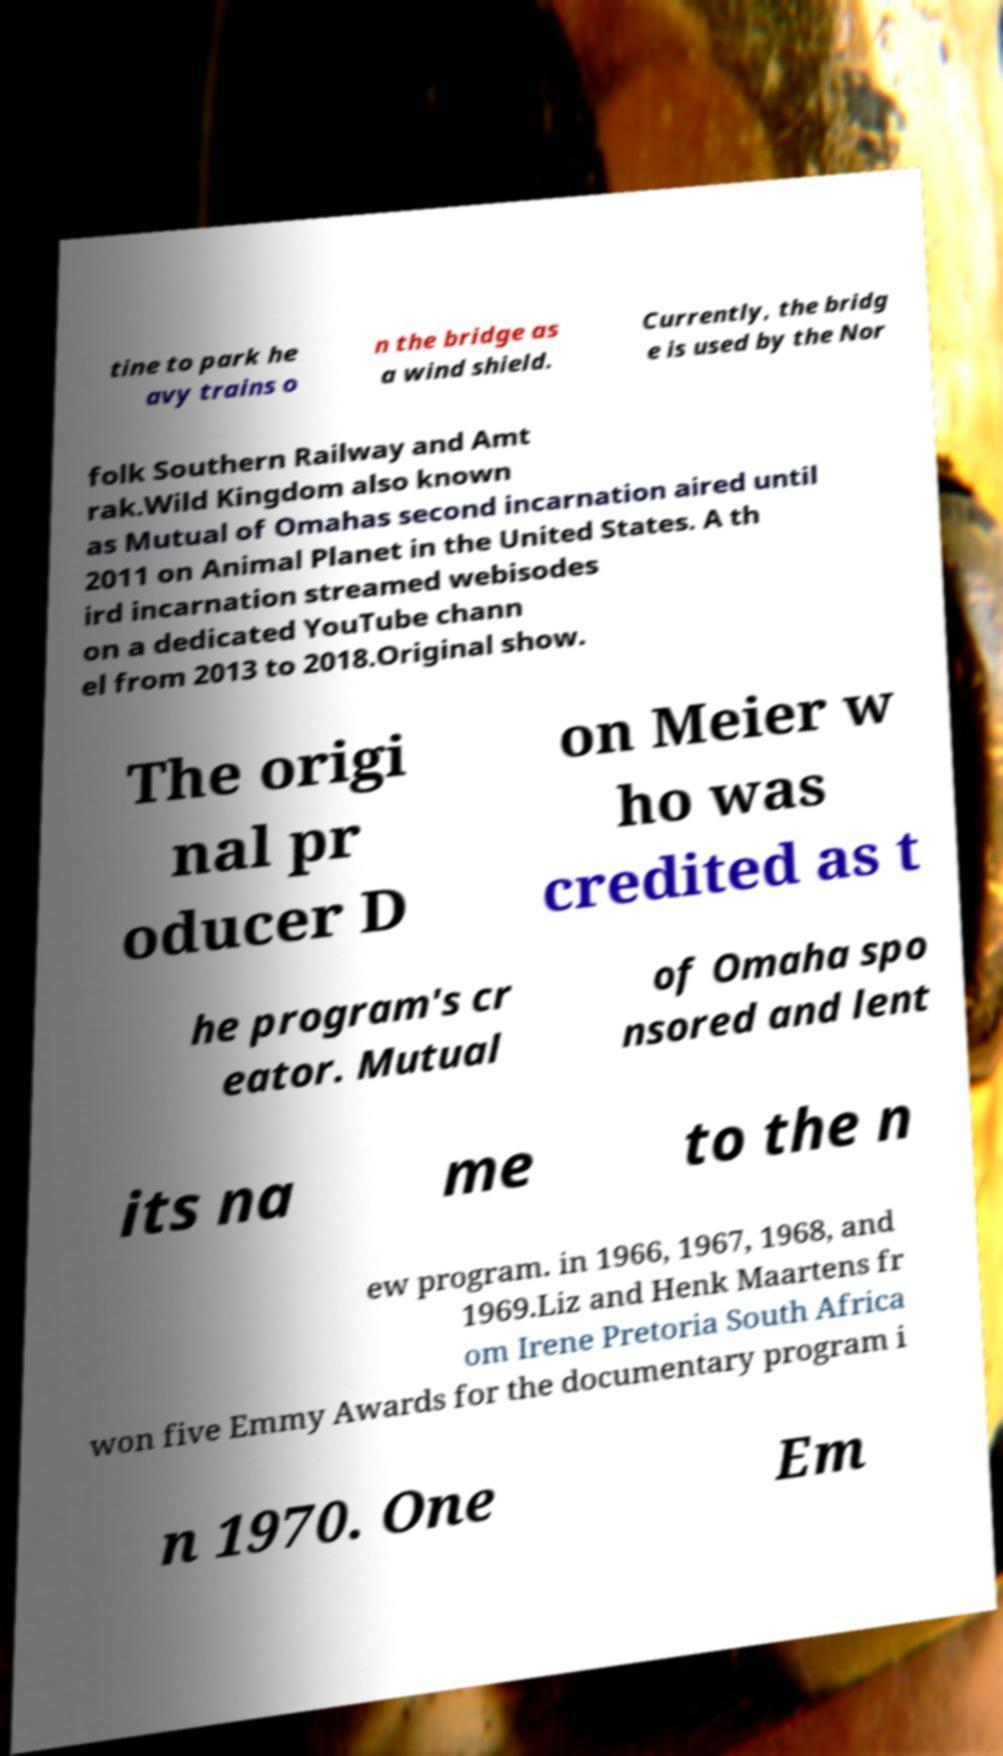I need the written content from this picture converted into text. Can you do that? tine to park he avy trains o n the bridge as a wind shield. Currently, the bridg e is used by the Nor folk Southern Railway and Amt rak.Wild Kingdom also known as Mutual of Omahas second incarnation aired until 2011 on Animal Planet in the United States. A th ird incarnation streamed webisodes on a dedicated YouTube chann el from 2013 to 2018.Original show. The origi nal pr oducer D on Meier w ho was credited as t he program's cr eator. Mutual of Omaha spo nsored and lent its na me to the n ew program. in 1966, 1967, 1968, and 1969.Liz and Henk Maartens fr om Irene Pretoria South Africa won five Emmy Awards for the documentary program i n 1970. One Em 